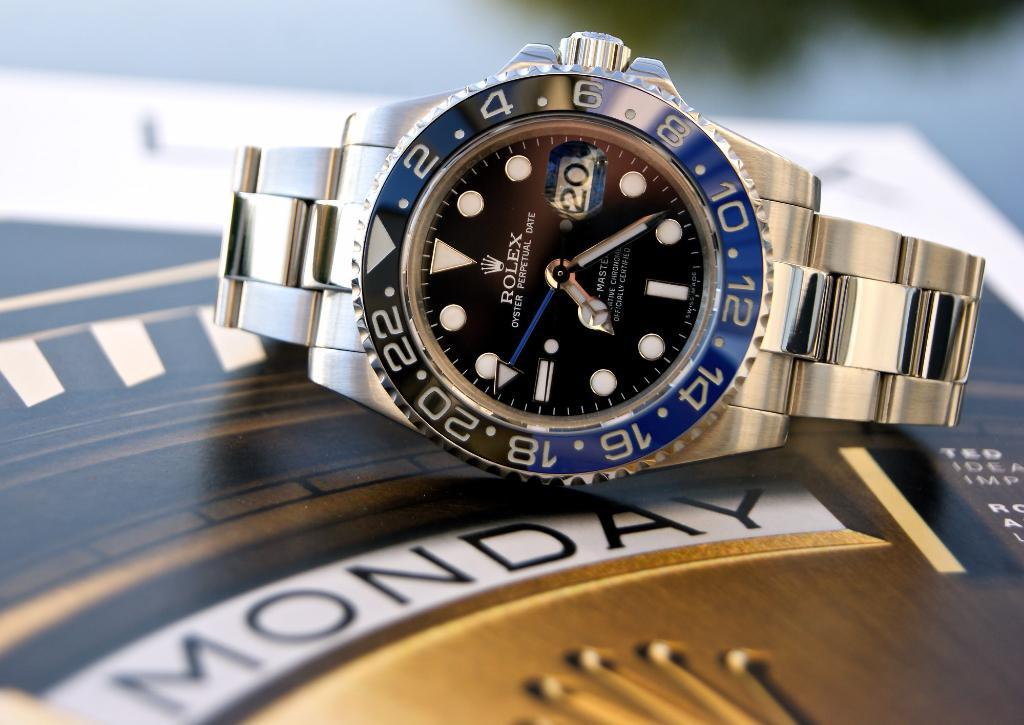What day is seen?
Provide a short and direct response. Monday. What time is shown?
Ensure brevity in your answer.  7:24. 